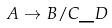Convert formula to latex. <formula><loc_0><loc_0><loc_500><loc_500>A \rightarrow B / C \_ D</formula> 